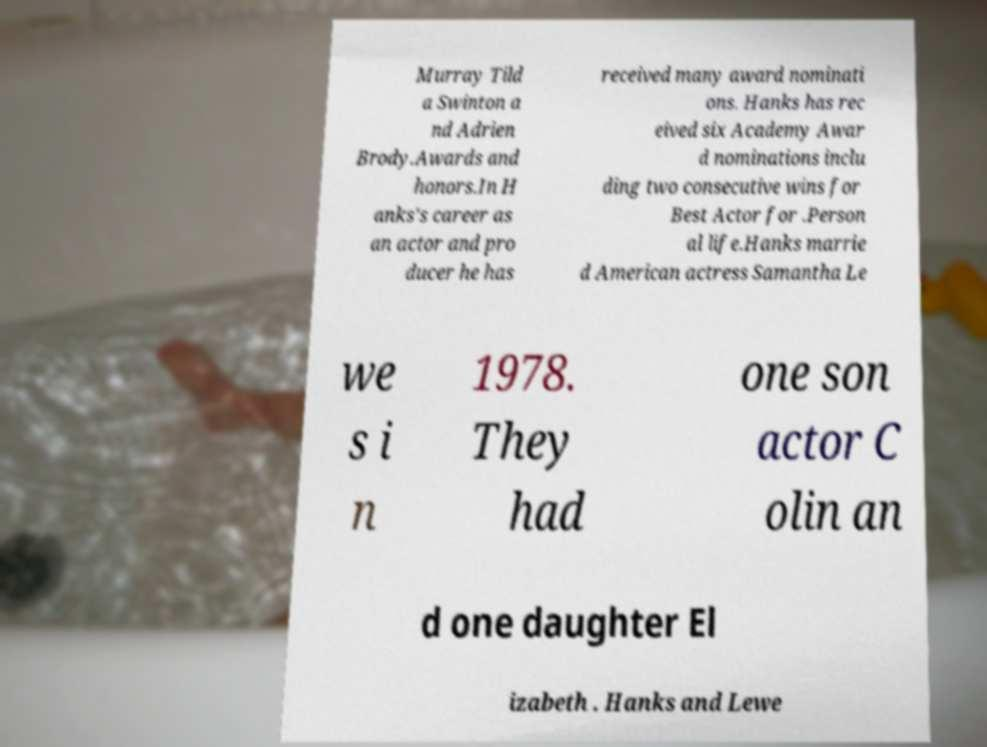Could you assist in decoding the text presented in this image and type it out clearly? Murray Tild a Swinton a nd Adrien Brody.Awards and honors.In H anks's career as an actor and pro ducer he has received many award nominati ons. Hanks has rec eived six Academy Awar d nominations inclu ding two consecutive wins for Best Actor for .Person al life.Hanks marrie d American actress Samantha Le we s i n 1978. They had one son actor C olin an d one daughter El izabeth . Hanks and Lewe 